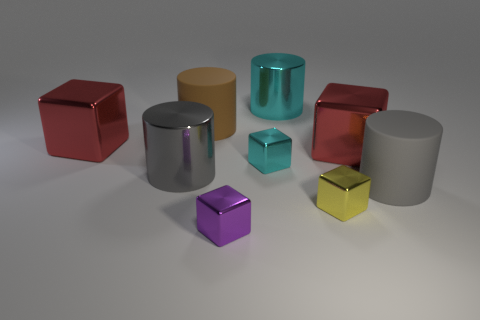What size is the cylinder that is both on the right side of the purple shiny object and behind the gray metal cylinder?
Your answer should be compact. Large. Is the material of the small purple cube the same as the large red cube right of the tiny purple cube?
Your answer should be compact. Yes. How many things are red blocks on the left side of the tiny purple cube or purple cylinders?
Provide a succinct answer. 1. There is a large metallic object that is on the right side of the tiny purple block and on the left side of the yellow block; what is its shape?
Ensure brevity in your answer.  Cylinder. Is there anything else that has the same size as the purple block?
Offer a terse response. Yes. The thing that is the same material as the big brown cylinder is what size?
Provide a short and direct response. Large. How many things are either large blocks right of the brown cylinder or cyan things that are behind the yellow cube?
Offer a very short reply. 3. Is the size of the red metal object that is to the right of the cyan block the same as the cyan metal block?
Give a very brief answer. No. What is the color of the large metallic block left of the large gray metallic cylinder?
Offer a terse response. Red. What color is the other shiny thing that is the same shape as the large cyan thing?
Ensure brevity in your answer.  Gray. 